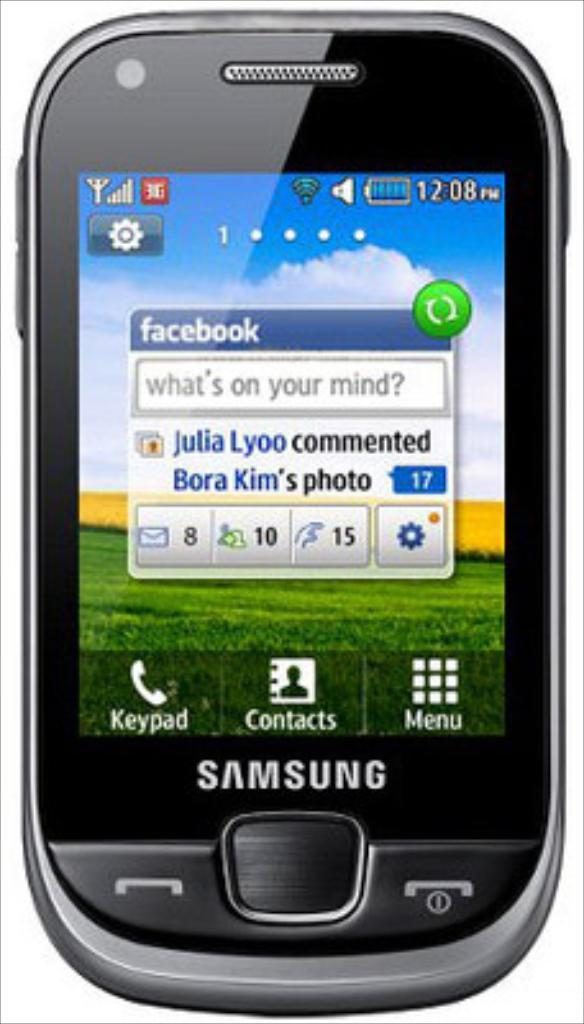<image>
Share a concise interpretation of the image provided. A black Samsung phone displays a notification from Facebook. 